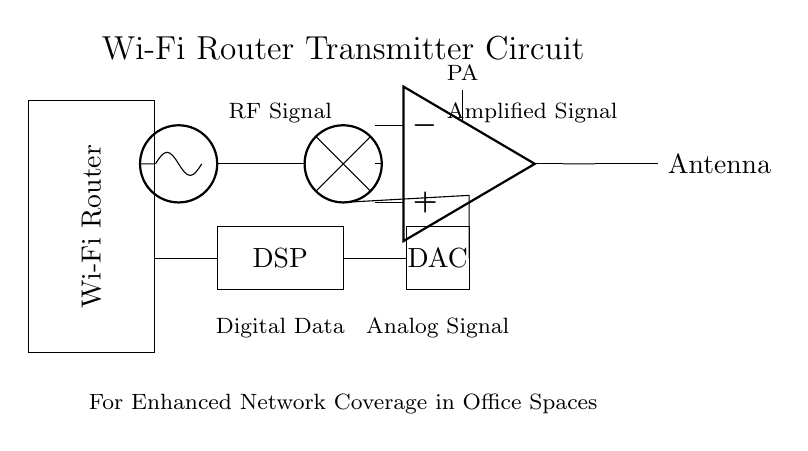What is the main function of the power amplifier? The main function of the power amplifier is to enhance the strength of the RF signal, increasing its power for transmission through the antenna.
Answer: Enhance signal strength What component is responsible for digital signal processing? The component responsible for digital signal processing is the digital signal processor, which converts digital data into a form suitable for transmission.
Answer: Digital signal processor How many main stages are involved in this Wi-Fi transmitter circuit? There are four main stages involved in the circuit: oscillator, mixer, power amplifier, and antenna.
Answer: Four stages What type of signal does the DAC convert? The digital-to-analog converter (DAC) converts a digital signal into an analog signal suitable for further processing and transmission.
Answer: Digital signal Where does the amplified signal exit the circuit? The amplified signal exits the circuit after passing through the power amplifier and is sent to the antenna for transmission.
Answer: Antenna What does the mixer do in this circuit? The mixer combines the RF signal from the oscillator with other signals to modulate the carrier wave for effective transmission.
Answer: Combine signals Which component receives the RF signal? The component that receives the RF signal is the oscillator, which generates the RF frequency necessary for communication.
Answer: Oscillator 